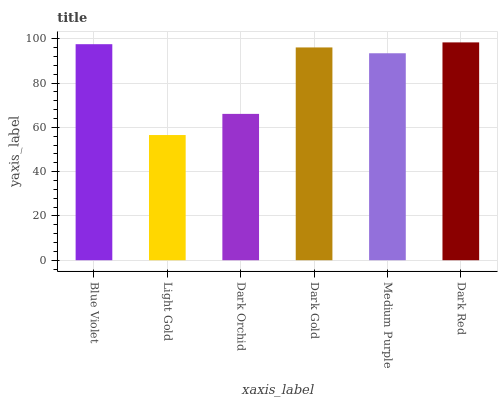Is Dark Orchid the minimum?
Answer yes or no. No. Is Dark Orchid the maximum?
Answer yes or no. No. Is Dark Orchid greater than Light Gold?
Answer yes or no. Yes. Is Light Gold less than Dark Orchid?
Answer yes or no. Yes. Is Light Gold greater than Dark Orchid?
Answer yes or no. No. Is Dark Orchid less than Light Gold?
Answer yes or no. No. Is Dark Gold the high median?
Answer yes or no. Yes. Is Medium Purple the low median?
Answer yes or no. Yes. Is Dark Orchid the high median?
Answer yes or no. No. Is Dark Red the low median?
Answer yes or no. No. 